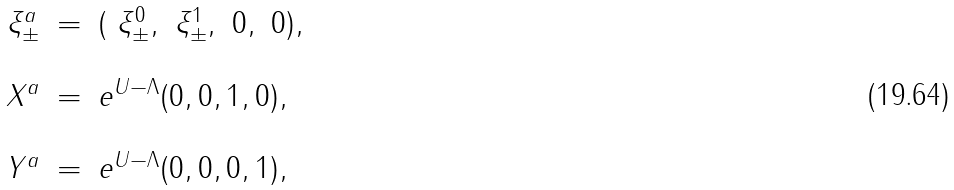Convert formula to latex. <formula><loc_0><loc_0><loc_500><loc_500>\begin{array} { c c l } \xi ^ { a } _ { \pm } & = & ( \ \xi ^ { 0 } _ { \pm } , \ \xi ^ { 1 } _ { \pm } , \ 0 , \ 0 ) , \\ & & \\ X ^ { a } & = & e ^ { U - \Lambda } ( 0 , 0 , 1 , 0 ) , \\ & & \\ Y ^ { a } & = & e ^ { U - \Lambda } ( 0 , 0 , 0 , 1 ) , \end{array}</formula> 